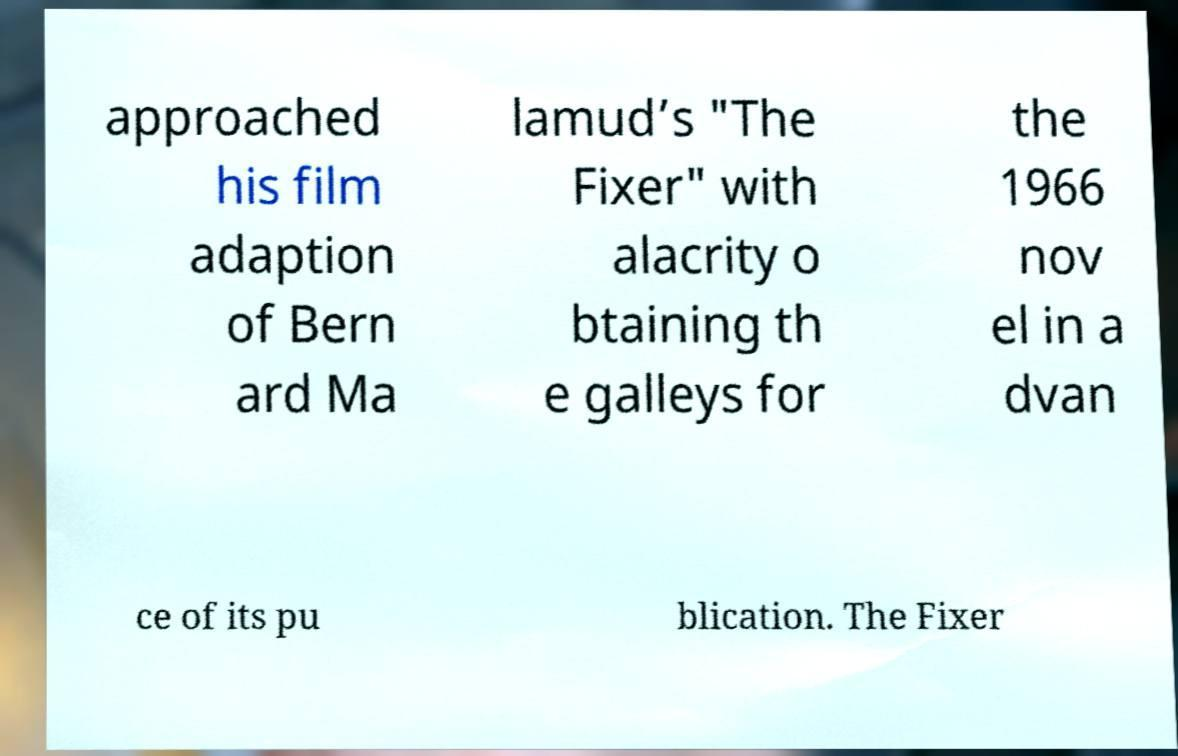Could you assist in decoding the text presented in this image and type it out clearly? approached his film adaption of Bern ard Ma lamud’s "The Fixer" with alacrity o btaining th e galleys for the 1966 nov el in a dvan ce of its pu blication. The Fixer 